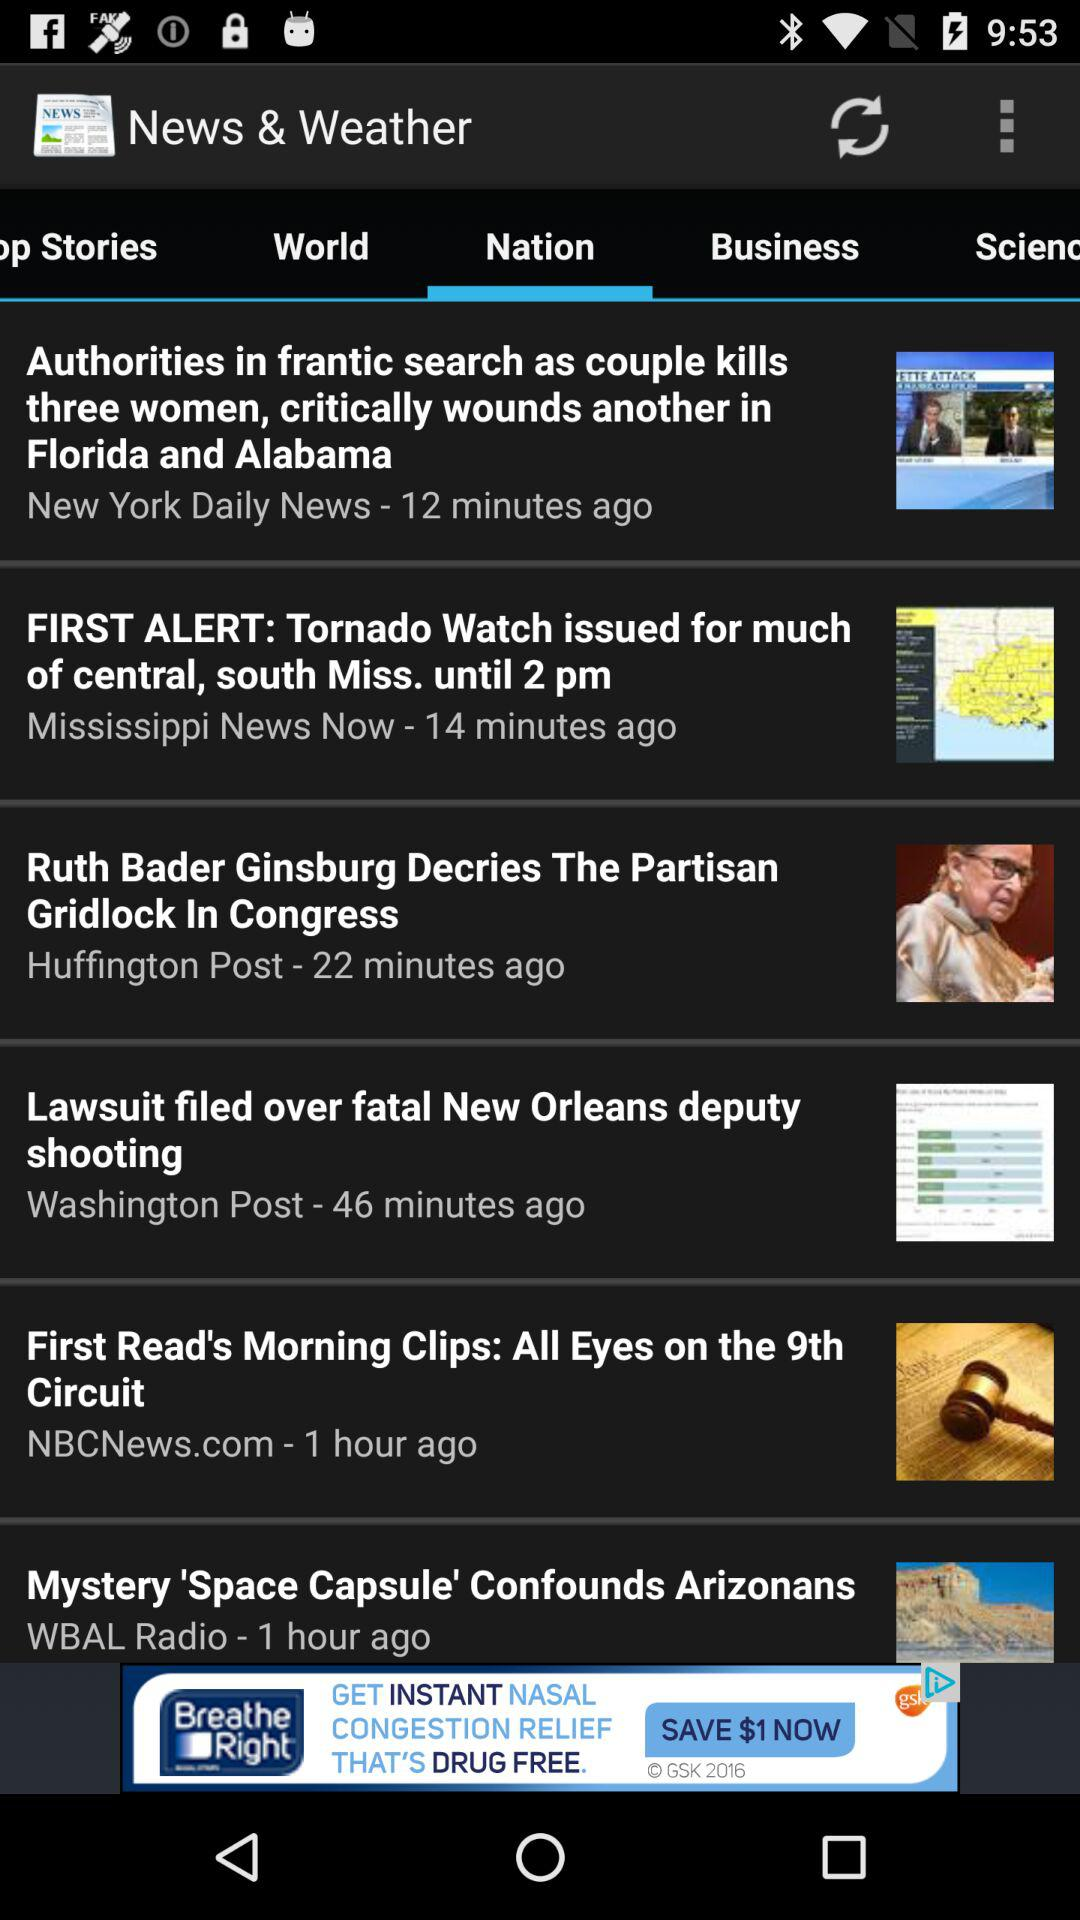When was "Ruth Bader Ginsburg Decries The Partisan Gridlock In Congress" posted? "Ruth Bader Ginsburg Decries The Partisan Gridlock In Congress" was posted 22 minutes ago. 